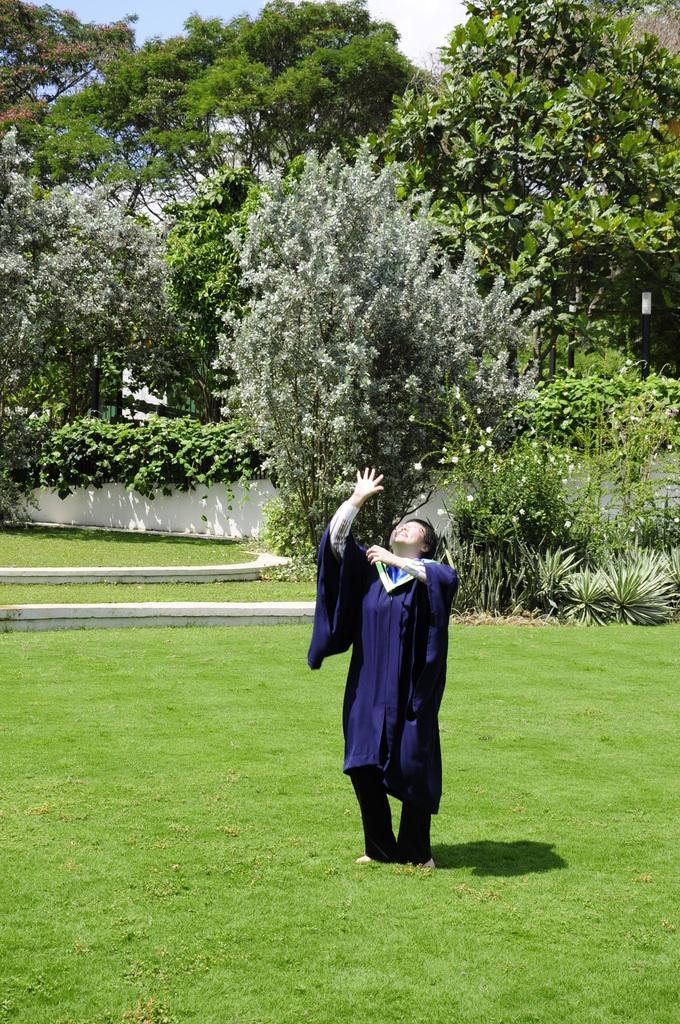Describe this image in one or two sentences. In this picture we can see a person standing on the grass and looking up. There are a few plants visible on the right side. We can see a few trees visible in the background. Sky is blue in color. 